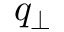Convert formula to latex. <formula><loc_0><loc_0><loc_500><loc_500>q _ { \perp }</formula> 